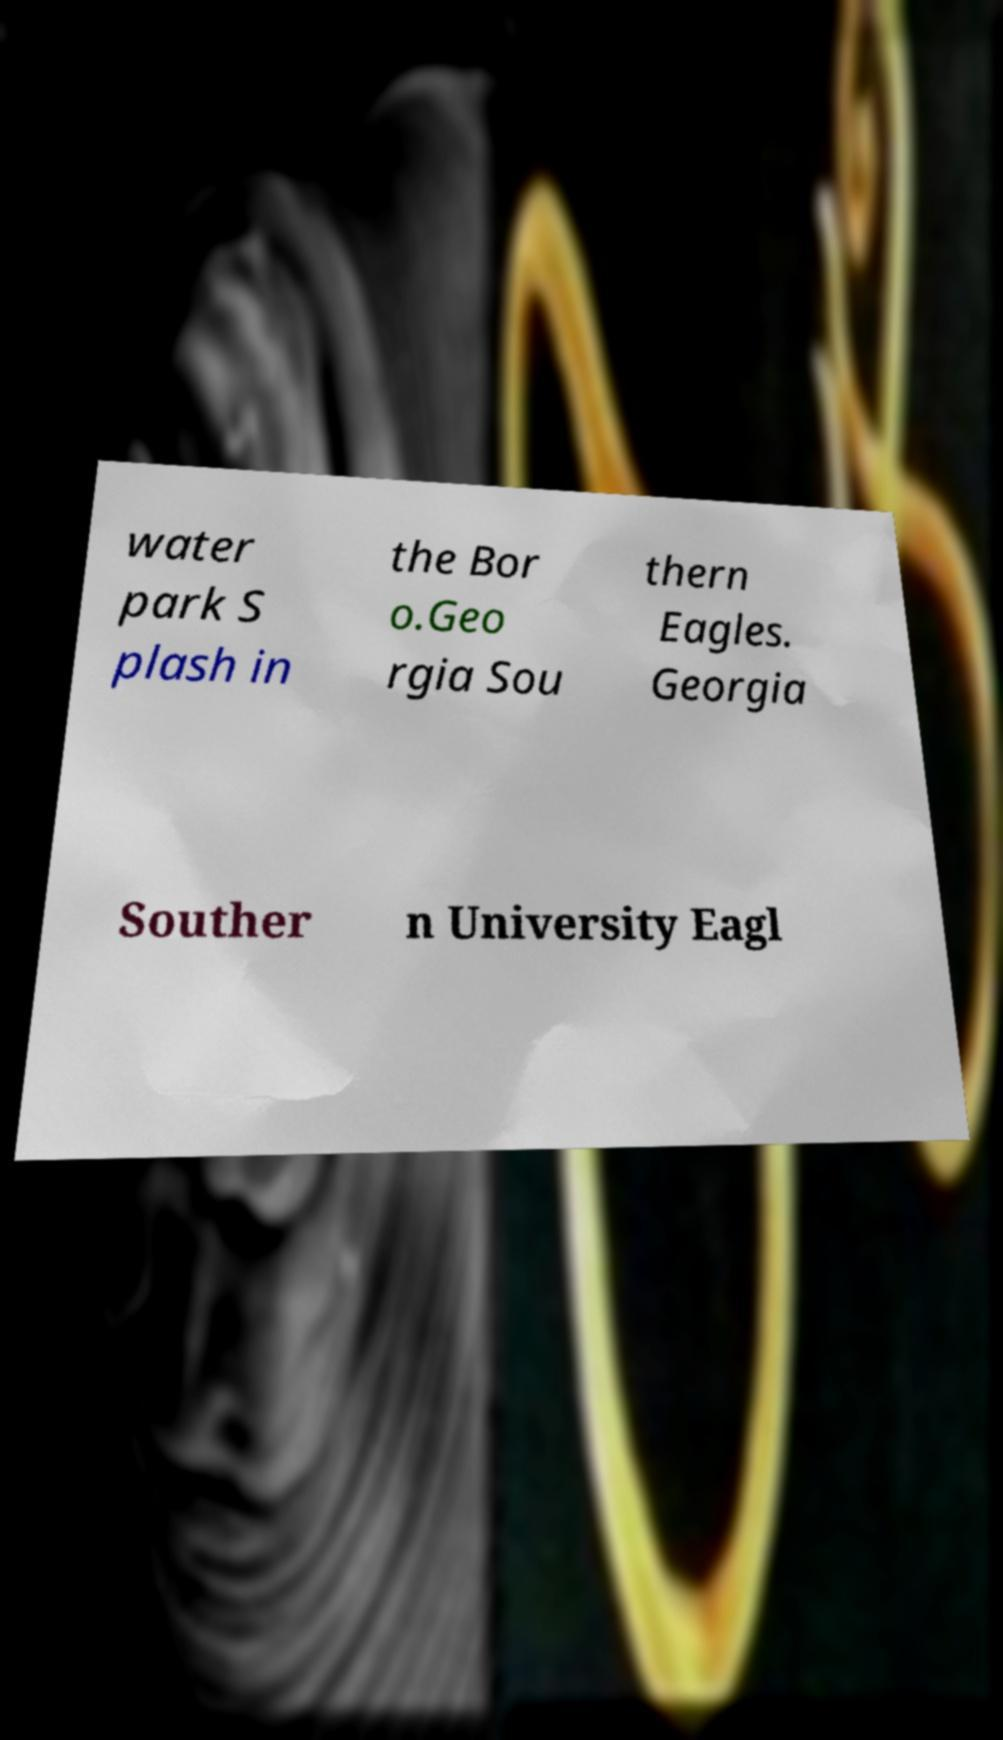Can you read and provide the text displayed in the image?This photo seems to have some interesting text. Can you extract and type it out for me? water park S plash in the Bor o.Geo rgia Sou thern Eagles. Georgia Souther n University Eagl 